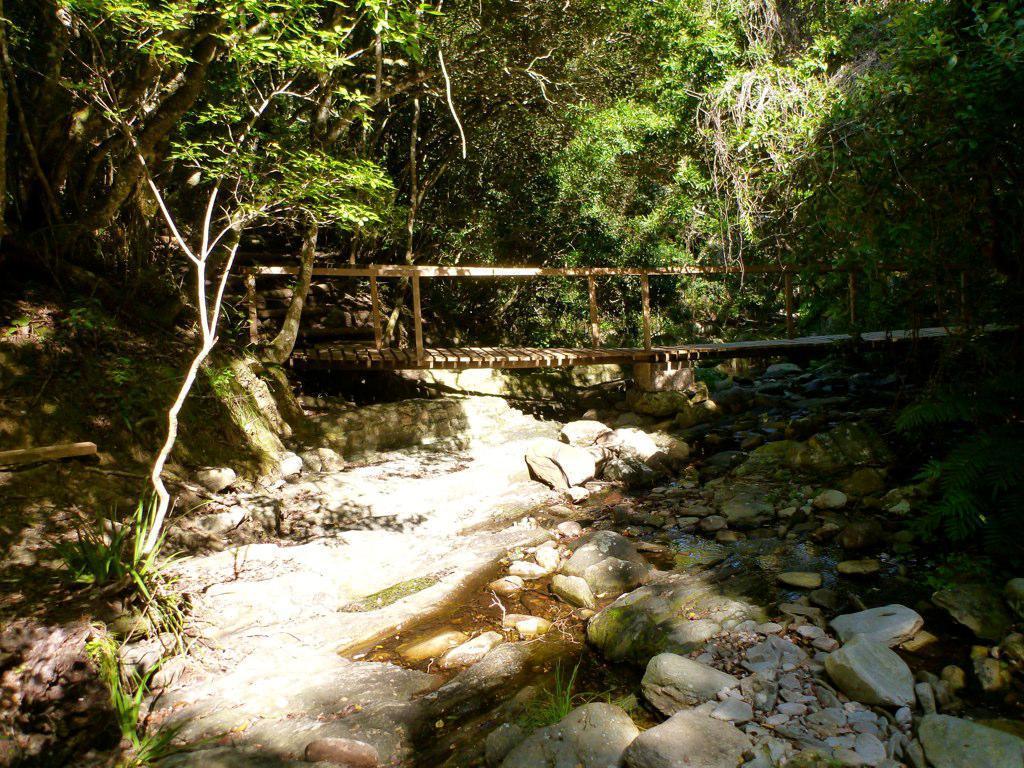Could you give a brief overview of what you see in this image? In this image there is a bridge. Below it there is water flow. Right side there are few rocks on the land having few plants and trees. 